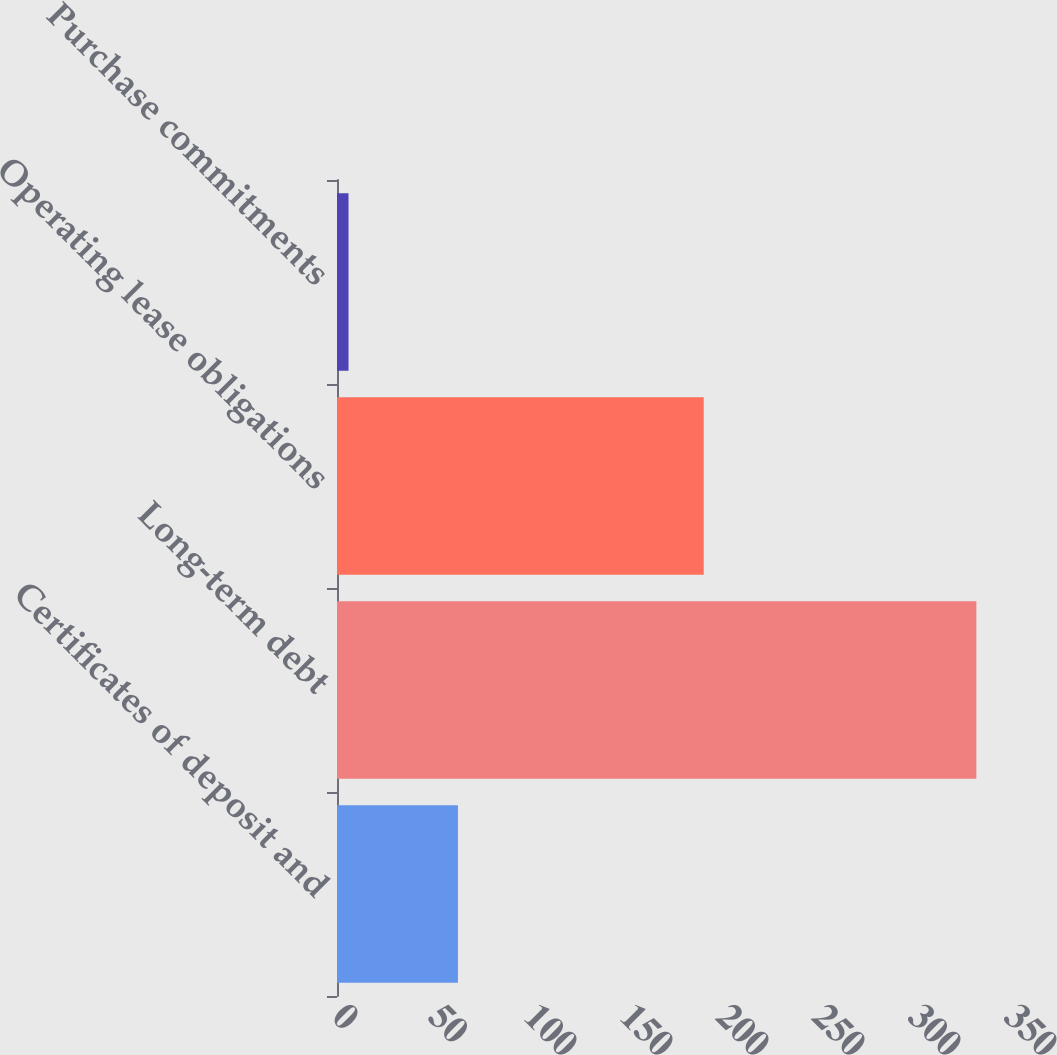Convert chart. <chart><loc_0><loc_0><loc_500><loc_500><bar_chart><fcel>Certificates of deposit and<fcel>Long-term debt<fcel>Operating lease obligations<fcel>Purchase commitments<nl><fcel>63<fcel>333<fcel>191<fcel>6<nl></chart> 